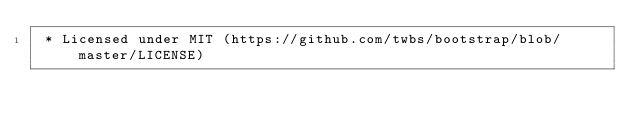<code> <loc_0><loc_0><loc_500><loc_500><_CSS_> * Licensed under MIT (https://github.com/twbs/bootstrap/blob/master/LICENSE)</code> 